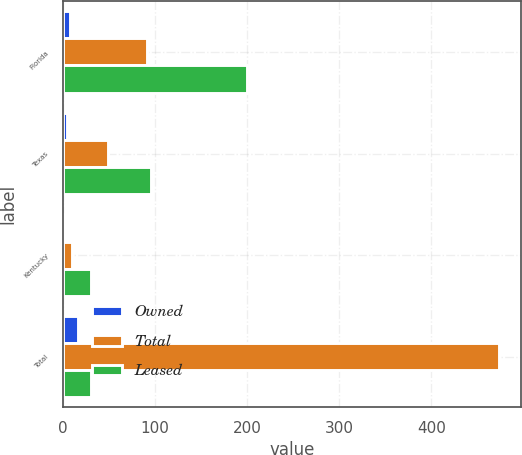<chart> <loc_0><loc_0><loc_500><loc_500><stacked_bar_chart><ecel><fcel>Florida<fcel>Texas<fcel>Kentucky<fcel>Total<nl><fcel>Owned<fcel>8<fcel>5<fcel>2<fcel>17<nl><fcel>Total<fcel>91<fcel>49<fcel>10<fcel>474<nl><fcel>Leased<fcel>200<fcel>96<fcel>31<fcel>31<nl></chart> 